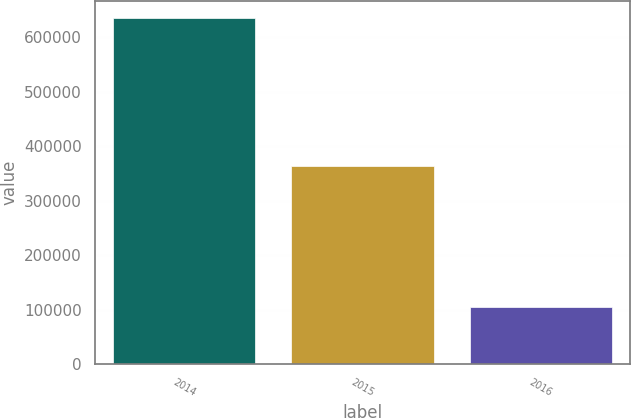<chart> <loc_0><loc_0><loc_500><loc_500><bar_chart><fcel>2014<fcel>2015<fcel>2016<nl><fcel>635000<fcel>363000<fcel>104000<nl></chart> 